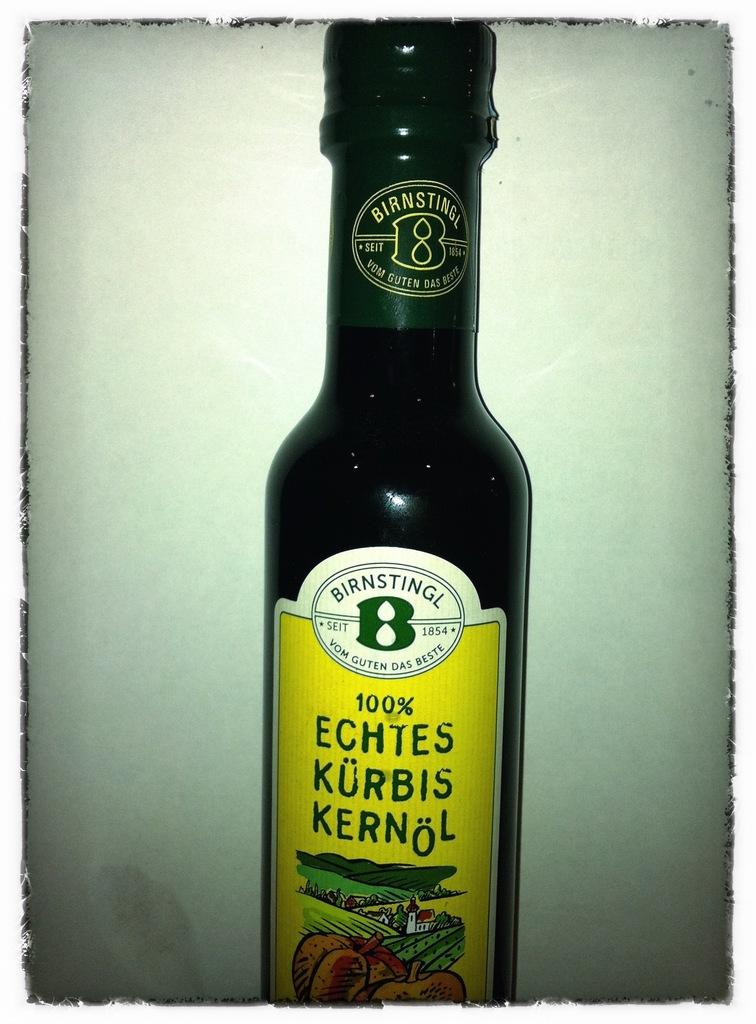<image>
Render a clear and concise summary of the photo. Green bottle with a yellow label that says 100% on it. 